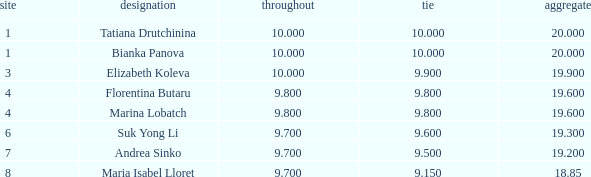8 and a 1 7.0. 